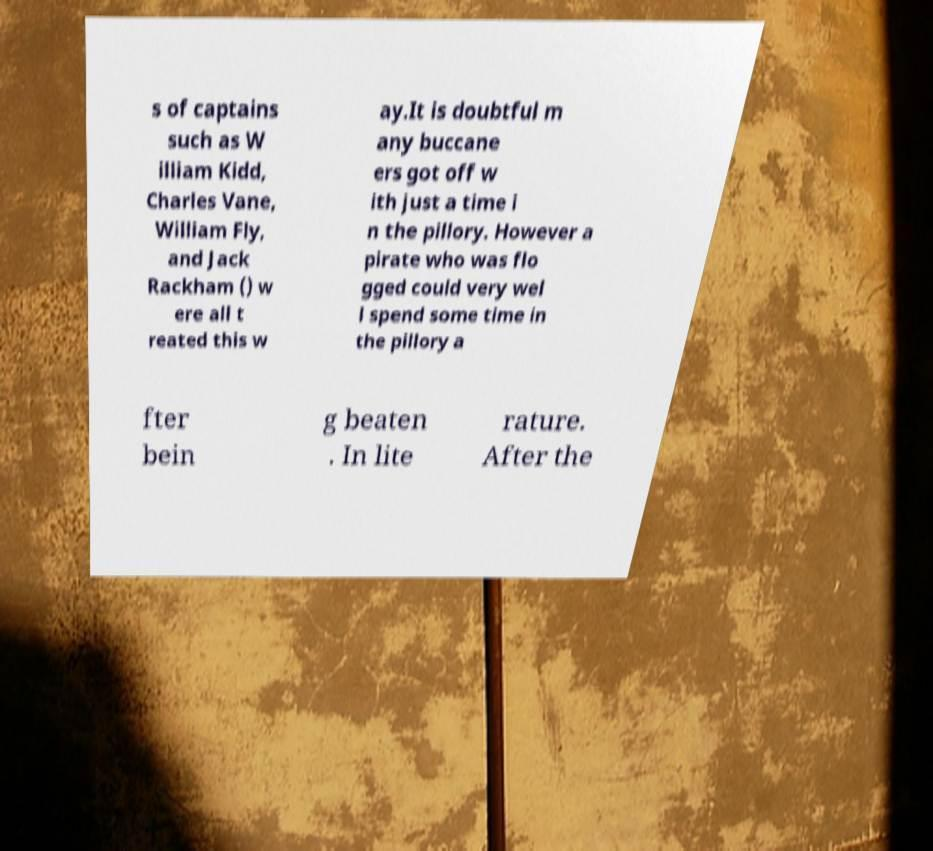Could you extract and type out the text from this image? s of captains such as W illiam Kidd, Charles Vane, William Fly, and Jack Rackham () w ere all t reated this w ay.It is doubtful m any buccane ers got off w ith just a time i n the pillory. However a pirate who was flo gged could very wel l spend some time in the pillory a fter bein g beaten . In lite rature. After the 